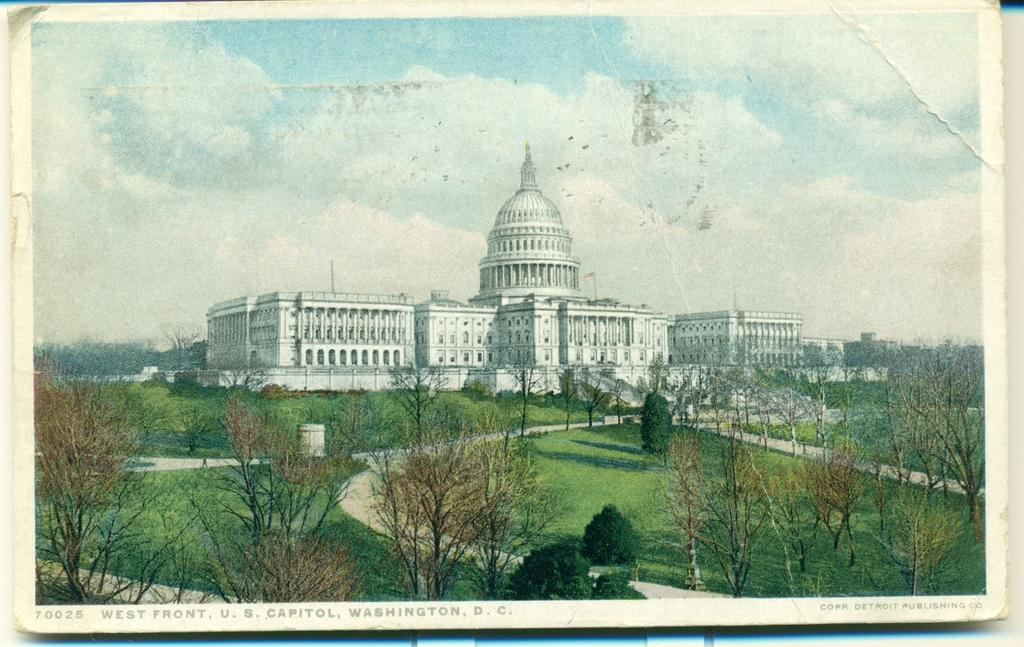What is depicted on the poster in the image? There is a poster of a place in the image. What type of natural elements can be seen in the image? There are trees in the image. What kind of pathway is visible in the image? There is a walkway in the image. What is the condition of the sky in the image? The sky is visible at the top of the image, and it is clear. Can you see any butter on the trees in the image? There is no butter present on the trees in the image. Is there a pipe visible in the image? There is no pipe present in the image. 